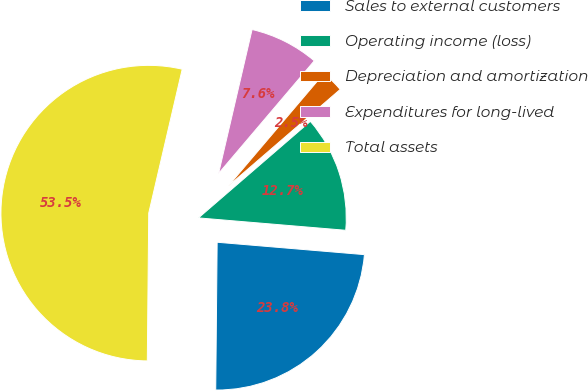<chart> <loc_0><loc_0><loc_500><loc_500><pie_chart><fcel>Sales to external customers<fcel>Operating income (loss)<fcel>Depreciation and amortization<fcel>Expenditures for long-lived<fcel>Total assets<nl><fcel>23.82%<fcel>12.67%<fcel>2.46%<fcel>7.57%<fcel>53.49%<nl></chart> 